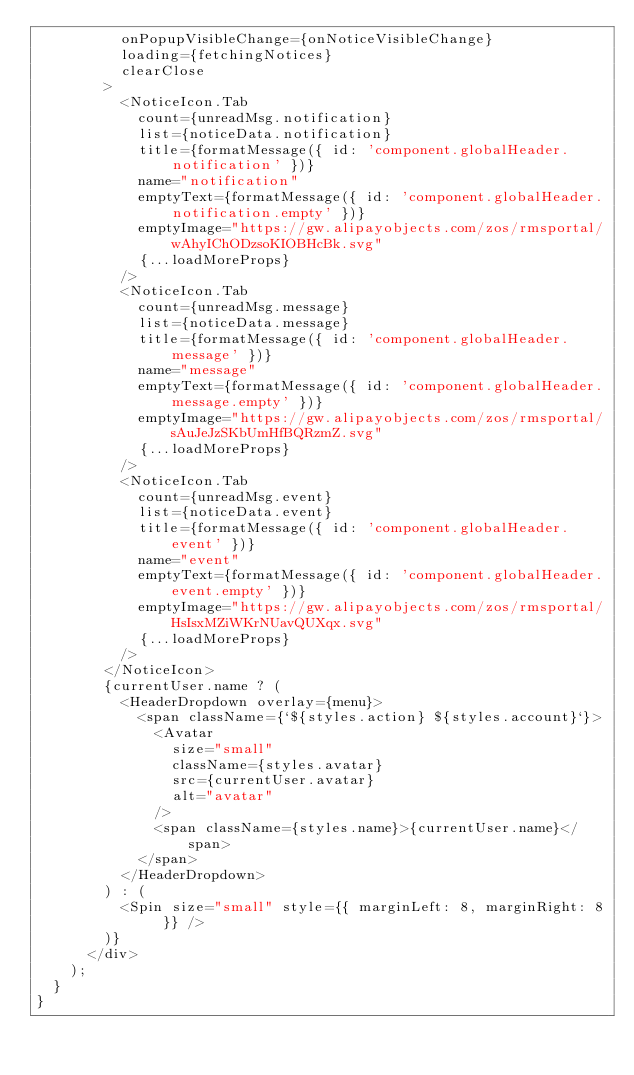Convert code to text. <code><loc_0><loc_0><loc_500><loc_500><_JavaScript_>          onPopupVisibleChange={onNoticeVisibleChange}
          loading={fetchingNotices}
          clearClose
        >
          <NoticeIcon.Tab
            count={unreadMsg.notification}
            list={noticeData.notification}
            title={formatMessage({ id: 'component.globalHeader.notification' })}
            name="notification"
            emptyText={formatMessage({ id: 'component.globalHeader.notification.empty' })}
            emptyImage="https://gw.alipayobjects.com/zos/rmsportal/wAhyIChODzsoKIOBHcBk.svg"
            {...loadMoreProps}
          />
          <NoticeIcon.Tab
            count={unreadMsg.message}
            list={noticeData.message}
            title={formatMessage({ id: 'component.globalHeader.message' })}
            name="message"
            emptyText={formatMessage({ id: 'component.globalHeader.message.empty' })}
            emptyImage="https://gw.alipayobjects.com/zos/rmsportal/sAuJeJzSKbUmHfBQRzmZ.svg"
            {...loadMoreProps}
          />
          <NoticeIcon.Tab
            count={unreadMsg.event}
            list={noticeData.event}
            title={formatMessage({ id: 'component.globalHeader.event' })}
            name="event"
            emptyText={formatMessage({ id: 'component.globalHeader.event.empty' })}
            emptyImage="https://gw.alipayobjects.com/zos/rmsportal/HsIsxMZiWKrNUavQUXqx.svg"
            {...loadMoreProps}
          />
        </NoticeIcon>
        {currentUser.name ? (
          <HeaderDropdown overlay={menu}>
            <span className={`${styles.action} ${styles.account}`}>
              <Avatar
                size="small"
                className={styles.avatar}
                src={currentUser.avatar}
                alt="avatar"
              />
              <span className={styles.name}>{currentUser.name}</span>
            </span>
          </HeaderDropdown>
        ) : (
          <Spin size="small" style={{ marginLeft: 8, marginRight: 8 }} />
        )}
      </div>
    );
  }
}
</code> 